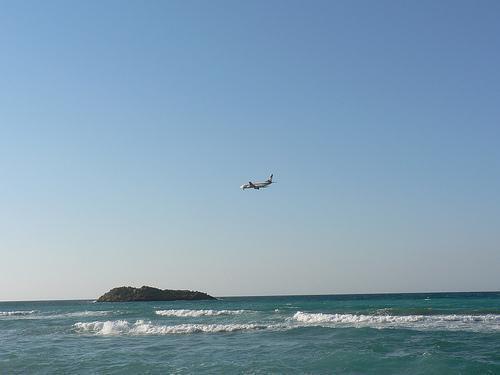How many planes are in the air?
Give a very brief answer. 1. 